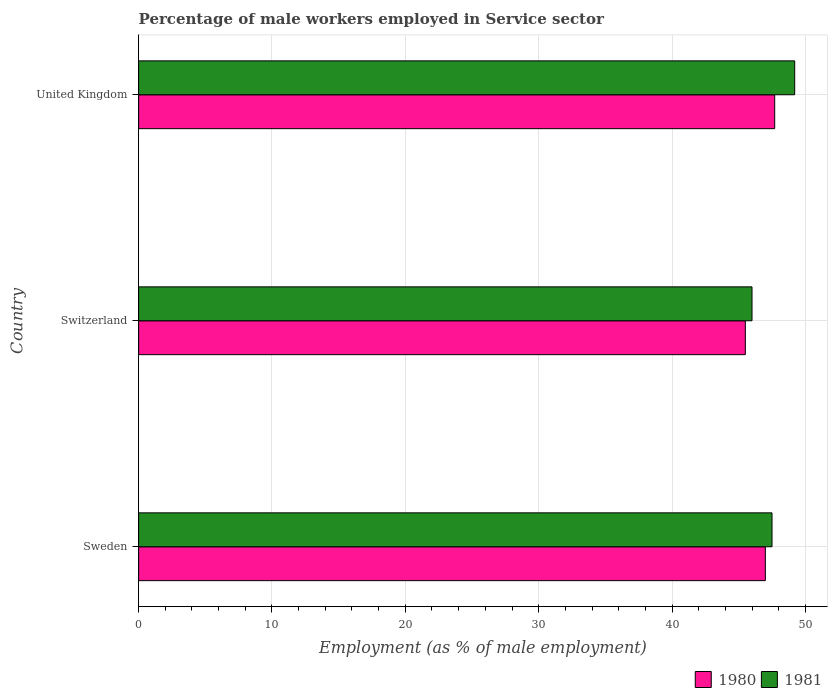Are the number of bars per tick equal to the number of legend labels?
Give a very brief answer. Yes. Are the number of bars on each tick of the Y-axis equal?
Offer a very short reply. Yes. How many bars are there on the 2nd tick from the bottom?
Make the answer very short. 2. What is the label of the 3rd group of bars from the top?
Your answer should be compact. Sweden. What is the percentage of male workers employed in Service sector in 1981 in United Kingdom?
Provide a succinct answer. 49.2. Across all countries, what is the maximum percentage of male workers employed in Service sector in 1980?
Offer a terse response. 47.7. Across all countries, what is the minimum percentage of male workers employed in Service sector in 1980?
Offer a very short reply. 45.5. In which country was the percentage of male workers employed in Service sector in 1981 minimum?
Your response must be concise. Switzerland. What is the total percentage of male workers employed in Service sector in 1981 in the graph?
Give a very brief answer. 142.7. What is the difference between the percentage of male workers employed in Service sector in 1980 in Sweden and that in United Kingdom?
Offer a very short reply. -0.7. What is the difference between the percentage of male workers employed in Service sector in 1980 in Switzerland and the percentage of male workers employed in Service sector in 1981 in United Kingdom?
Offer a terse response. -3.7. What is the average percentage of male workers employed in Service sector in 1980 per country?
Make the answer very short. 46.73. What is the ratio of the percentage of male workers employed in Service sector in 1981 in Switzerland to that in United Kingdom?
Give a very brief answer. 0.93. What is the difference between the highest and the second highest percentage of male workers employed in Service sector in 1980?
Make the answer very short. 0.7. What is the difference between the highest and the lowest percentage of male workers employed in Service sector in 1980?
Your response must be concise. 2.2. In how many countries, is the percentage of male workers employed in Service sector in 1980 greater than the average percentage of male workers employed in Service sector in 1980 taken over all countries?
Ensure brevity in your answer.  2. Is the sum of the percentage of male workers employed in Service sector in 1980 in Sweden and United Kingdom greater than the maximum percentage of male workers employed in Service sector in 1981 across all countries?
Provide a short and direct response. Yes. How many bars are there?
Offer a very short reply. 6. How many countries are there in the graph?
Ensure brevity in your answer.  3. What is the difference between two consecutive major ticks on the X-axis?
Your answer should be compact. 10. Are the values on the major ticks of X-axis written in scientific E-notation?
Provide a short and direct response. No. Does the graph contain any zero values?
Offer a very short reply. No. Does the graph contain grids?
Your answer should be compact. Yes. Where does the legend appear in the graph?
Your answer should be very brief. Bottom right. How many legend labels are there?
Your response must be concise. 2. How are the legend labels stacked?
Offer a very short reply. Horizontal. What is the title of the graph?
Ensure brevity in your answer.  Percentage of male workers employed in Service sector. What is the label or title of the X-axis?
Keep it short and to the point. Employment (as % of male employment). What is the label or title of the Y-axis?
Make the answer very short. Country. What is the Employment (as % of male employment) in 1980 in Sweden?
Keep it short and to the point. 47. What is the Employment (as % of male employment) of 1981 in Sweden?
Make the answer very short. 47.5. What is the Employment (as % of male employment) of 1980 in Switzerland?
Give a very brief answer. 45.5. What is the Employment (as % of male employment) in 1980 in United Kingdom?
Your answer should be very brief. 47.7. What is the Employment (as % of male employment) in 1981 in United Kingdom?
Your response must be concise. 49.2. Across all countries, what is the maximum Employment (as % of male employment) in 1980?
Offer a very short reply. 47.7. Across all countries, what is the maximum Employment (as % of male employment) of 1981?
Offer a terse response. 49.2. Across all countries, what is the minimum Employment (as % of male employment) of 1980?
Provide a succinct answer. 45.5. What is the total Employment (as % of male employment) in 1980 in the graph?
Ensure brevity in your answer.  140.2. What is the total Employment (as % of male employment) of 1981 in the graph?
Make the answer very short. 142.7. What is the difference between the Employment (as % of male employment) in 1981 in Sweden and that in Switzerland?
Offer a very short reply. 1.5. What is the difference between the Employment (as % of male employment) in 1980 in Sweden and that in United Kingdom?
Your answer should be very brief. -0.7. What is the difference between the Employment (as % of male employment) in 1981 in Sweden and that in United Kingdom?
Make the answer very short. -1.7. What is the difference between the Employment (as % of male employment) of 1980 in Sweden and the Employment (as % of male employment) of 1981 in Switzerland?
Make the answer very short. 1. What is the difference between the Employment (as % of male employment) in 1980 in Switzerland and the Employment (as % of male employment) in 1981 in United Kingdom?
Offer a terse response. -3.7. What is the average Employment (as % of male employment) of 1980 per country?
Offer a terse response. 46.73. What is the average Employment (as % of male employment) of 1981 per country?
Give a very brief answer. 47.57. What is the difference between the Employment (as % of male employment) in 1980 and Employment (as % of male employment) in 1981 in Sweden?
Your answer should be very brief. -0.5. What is the difference between the Employment (as % of male employment) of 1980 and Employment (as % of male employment) of 1981 in Switzerland?
Your answer should be compact. -0.5. What is the difference between the Employment (as % of male employment) in 1980 and Employment (as % of male employment) in 1981 in United Kingdom?
Provide a succinct answer. -1.5. What is the ratio of the Employment (as % of male employment) in 1980 in Sweden to that in Switzerland?
Ensure brevity in your answer.  1.03. What is the ratio of the Employment (as % of male employment) of 1981 in Sweden to that in Switzerland?
Offer a very short reply. 1.03. What is the ratio of the Employment (as % of male employment) in 1981 in Sweden to that in United Kingdom?
Provide a succinct answer. 0.97. What is the ratio of the Employment (as % of male employment) in 1980 in Switzerland to that in United Kingdom?
Ensure brevity in your answer.  0.95. What is the ratio of the Employment (as % of male employment) of 1981 in Switzerland to that in United Kingdom?
Offer a terse response. 0.94. What is the difference between the highest and the second highest Employment (as % of male employment) in 1980?
Give a very brief answer. 0.7. What is the difference between the highest and the lowest Employment (as % of male employment) in 1980?
Provide a succinct answer. 2.2. 